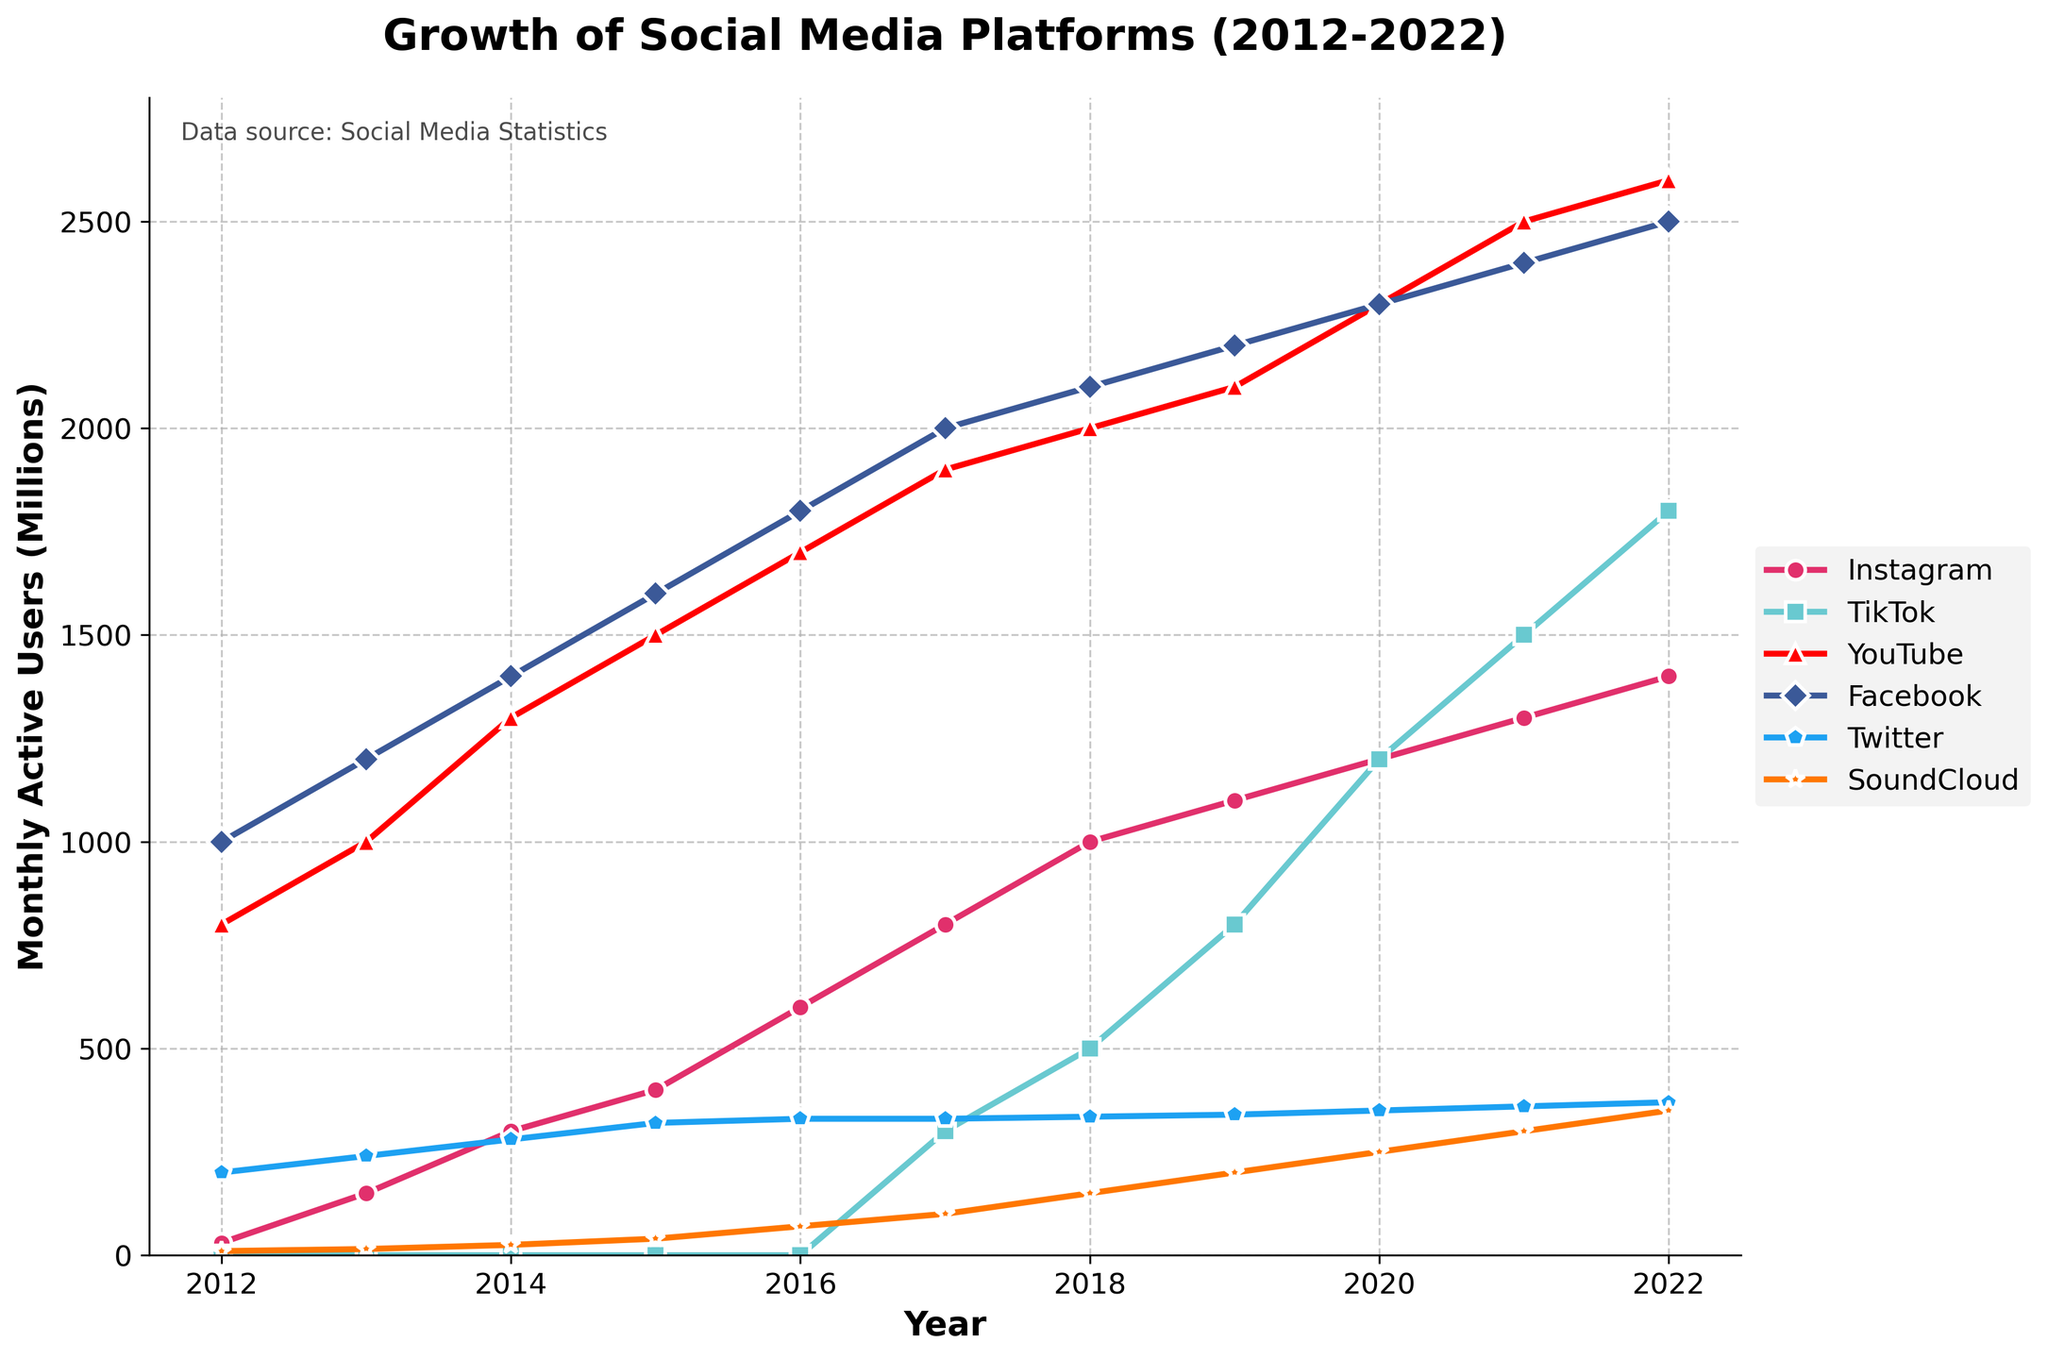Which platform had the highest percentage increase in monthly active users from 2017 to 2022? To determine this, calculate the percentage increase for each platform from 2017 to 2022. For Instagram, it increased from 800 to 1400: ((1400 - 800) / 800) * 100 = 75%. For TikTok, it went from 300 to 1800: ((1800 - 300) / 300) * 100 = 500%. Continue this calculation for each platform. TikTok shows the highest increase
Answer: TikTok Which platform had the slowest growth in monthly active users over the decade? Examine the growth from 2012 to 2022 for each platform. Instagram increased from 30 to 1400, TikTok from 0 to 1800, YouTube from 800 to 2600, Facebook from 1000 to 2500, Twitter from 200 to 370, and SoundCloud from 10 to 350. The slowest growth is determined by the smallest difference. Twitter grew the slowest
Answer: Twitter In which year did TikTok surpass Instagram in monthly active users? Track the user count for both TikTok and Instagram year by year. Notably, Instagram had a higher user count until 2020 when TikTok had 1200 and Instagram had 1200, and 2021 when TikTok had 1500 and Instagram had 1300. Thus, TikTok first surpassed Instagram in 2021
Answer: 2021 How many platforms reached at least 2000 million monthly active users by the year 2022? Check the 2022 data: Instagram (1400), TikTok (1800), YouTube (2600), Facebook (2500), Twitter (370), SoundCloud (350). Only YouTube and Facebook crossed 2000 million
Answer: 2 Which year showed the most significant growth for SoundCloud? Evaluate the year-over-year differences in SoundCloud's user base. The differences are: 2013-5, 2014-10, 2015-15, 2016-30, 2017-30, 2018-50, 2019-50, 2020-50, 2021-50, 2022-50. SoundCloud saw the largest increase in users in 2018, 2019, 2020, 2021, and 2022 with each having a growth of 50 million
Answer: 2018, 2019, 2020, 2021, 2022 What was the combined total of monthly active users for Instagram and SoundCloud in 2015? Add the monthly active users of Instagram (400) and SoundCloud (40) for 2015: 400 + 40 = 440 million
Answer: 440 million Which platform had no users recorded until 2017? Reviewing the data, TikTok had 0 users from 2012 to 2016 and began recording users in 2017
Answer: TikTok What is the difference in monthly active users between YouTube and Facebook in 2022? Subtract Facebook’s 2022 user count (2500) from YouTube’s (2600): 2600 - 2500 = 100 million
Answer: 100 million Which platform experienced consistent linear growth every year from 2017 to 2022? By observing the trends, TikTok shows a linear increase from 2017 (300) to 2022 (1800) with a steady increase each year
Answer: TikTok 